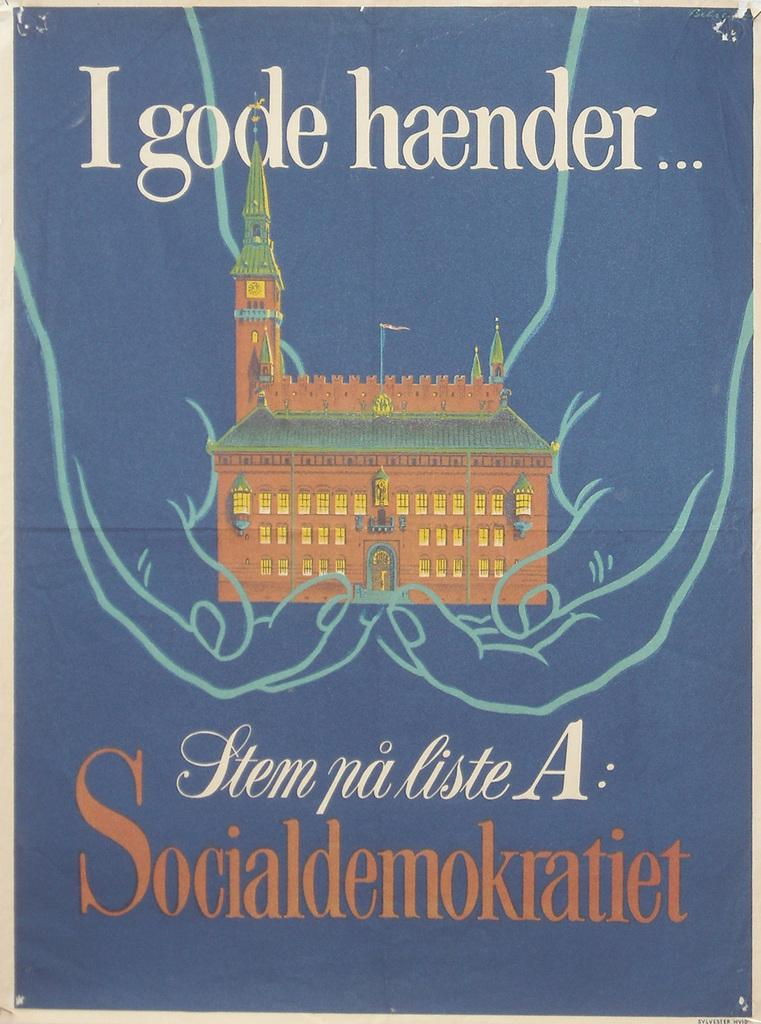<image>
Provide a brief description of the given image. Two hands hold a large building on the cover of a German book. 